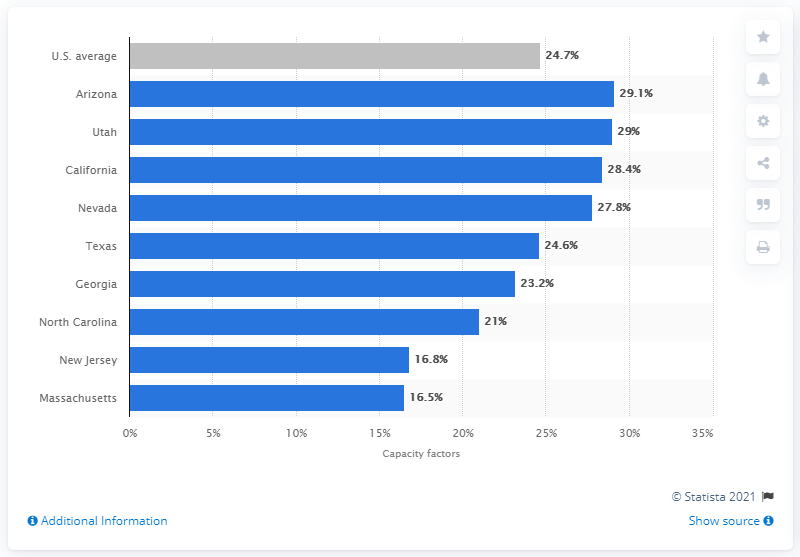Highlight a few significant elements in this photo. The average of New Jersey and Massachusetts is 16.65. The result of the analysis showed that two states had a percentage of less than 20% of their registered voters using the mobile application. Arizona's solar photovoltaic (PV) capacity factor was 29.1% between 2014 and 2017. 